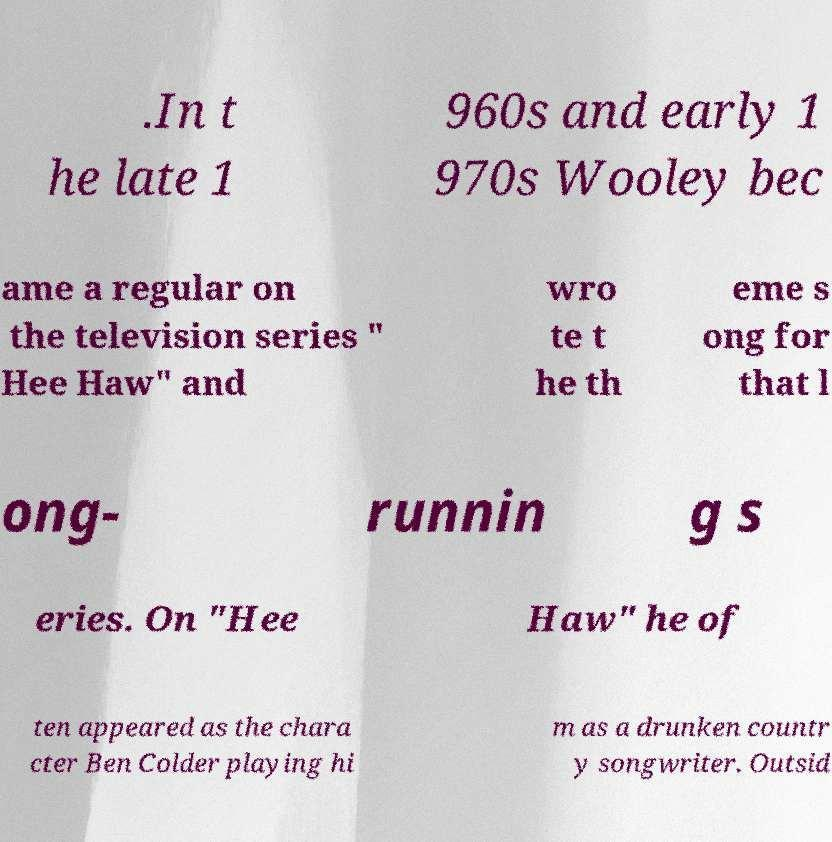I need the written content from this picture converted into text. Can you do that? .In t he late 1 960s and early 1 970s Wooley bec ame a regular on the television series " Hee Haw" and wro te t he th eme s ong for that l ong- runnin g s eries. On "Hee Haw" he of ten appeared as the chara cter Ben Colder playing hi m as a drunken countr y songwriter. Outsid 